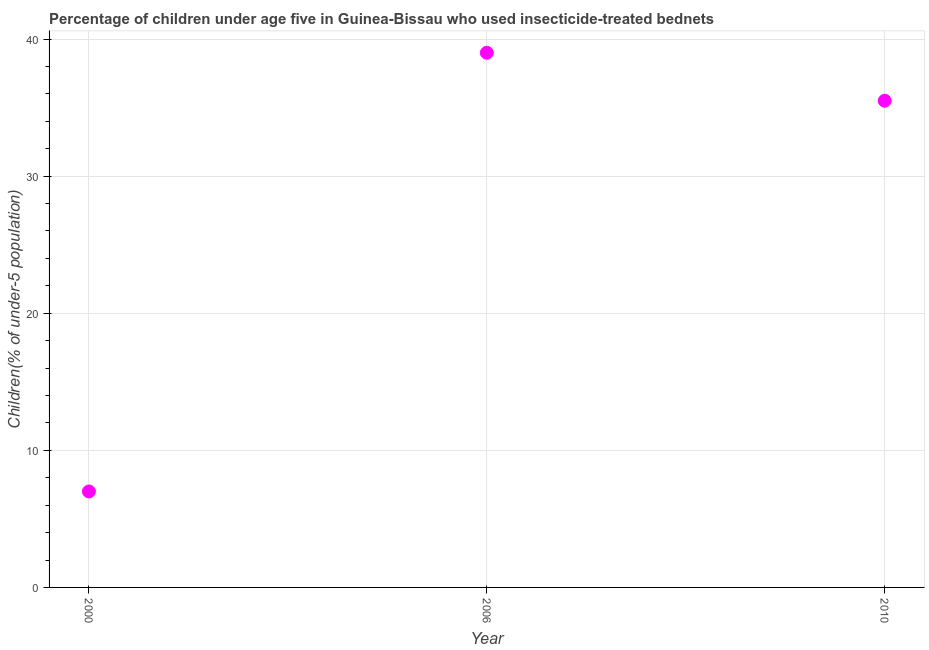What is the percentage of children who use of insecticide-treated bed nets in 2000?
Your response must be concise. 7. What is the sum of the percentage of children who use of insecticide-treated bed nets?
Offer a terse response. 81.5. What is the difference between the percentage of children who use of insecticide-treated bed nets in 2000 and 2010?
Your answer should be compact. -28.5. What is the average percentage of children who use of insecticide-treated bed nets per year?
Offer a terse response. 27.17. What is the median percentage of children who use of insecticide-treated bed nets?
Provide a short and direct response. 35.5. What is the ratio of the percentage of children who use of insecticide-treated bed nets in 2006 to that in 2010?
Offer a terse response. 1.1. Is the difference between the percentage of children who use of insecticide-treated bed nets in 2006 and 2010 greater than the difference between any two years?
Your answer should be very brief. No. What is the difference between the highest and the lowest percentage of children who use of insecticide-treated bed nets?
Offer a terse response. 32. In how many years, is the percentage of children who use of insecticide-treated bed nets greater than the average percentage of children who use of insecticide-treated bed nets taken over all years?
Your answer should be compact. 2. How many years are there in the graph?
Make the answer very short. 3. What is the difference between two consecutive major ticks on the Y-axis?
Make the answer very short. 10. Does the graph contain any zero values?
Your response must be concise. No. What is the title of the graph?
Keep it short and to the point. Percentage of children under age five in Guinea-Bissau who used insecticide-treated bednets. What is the label or title of the Y-axis?
Provide a succinct answer. Children(% of under-5 population). What is the Children(% of under-5 population) in 2006?
Make the answer very short. 39. What is the Children(% of under-5 population) in 2010?
Keep it short and to the point. 35.5. What is the difference between the Children(% of under-5 population) in 2000 and 2006?
Make the answer very short. -32. What is the difference between the Children(% of under-5 population) in 2000 and 2010?
Your response must be concise. -28.5. What is the difference between the Children(% of under-5 population) in 2006 and 2010?
Your answer should be compact. 3.5. What is the ratio of the Children(% of under-5 population) in 2000 to that in 2006?
Ensure brevity in your answer.  0.18. What is the ratio of the Children(% of under-5 population) in 2000 to that in 2010?
Give a very brief answer. 0.2. What is the ratio of the Children(% of under-5 population) in 2006 to that in 2010?
Your answer should be very brief. 1.1. 